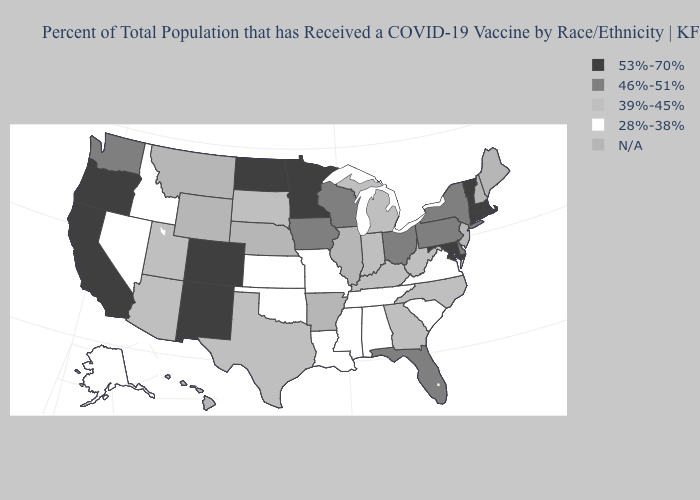Name the states that have a value in the range N/A?
Short answer required. Arkansas, Hawaii, Illinois, Maine, Montana, Nebraska, New Hampshire, New Jersey, Wyoming. Name the states that have a value in the range 39%-45%?
Concise answer only. Arizona, Georgia, Indiana, Kentucky, Michigan, North Carolina, South Dakota, Texas, Utah, West Virginia. Name the states that have a value in the range 46%-51%?
Be succinct. Delaware, Florida, Iowa, New York, Ohio, Pennsylvania, Washington, Wisconsin. What is the value of Wyoming?
Concise answer only. N/A. What is the value of Hawaii?
Keep it brief. N/A. Which states have the lowest value in the USA?
Give a very brief answer. Alabama, Alaska, Idaho, Kansas, Louisiana, Mississippi, Missouri, Nevada, Oklahoma, South Carolina, Tennessee, Virginia. Name the states that have a value in the range N/A?
Short answer required. Arkansas, Hawaii, Illinois, Maine, Montana, Nebraska, New Hampshire, New Jersey, Wyoming. What is the value of Pennsylvania?
Short answer required. 46%-51%. Does Tennessee have the lowest value in the South?
Give a very brief answer. Yes. What is the value of Kentucky?
Concise answer only. 39%-45%. What is the value of Arizona?
Answer briefly. 39%-45%. Name the states that have a value in the range N/A?
Concise answer only. Arkansas, Hawaii, Illinois, Maine, Montana, Nebraska, New Hampshire, New Jersey, Wyoming. Name the states that have a value in the range N/A?
Give a very brief answer. Arkansas, Hawaii, Illinois, Maine, Montana, Nebraska, New Hampshire, New Jersey, Wyoming. What is the value of Maine?
Be succinct. N/A. Does Kansas have the lowest value in the MidWest?
Concise answer only. Yes. 